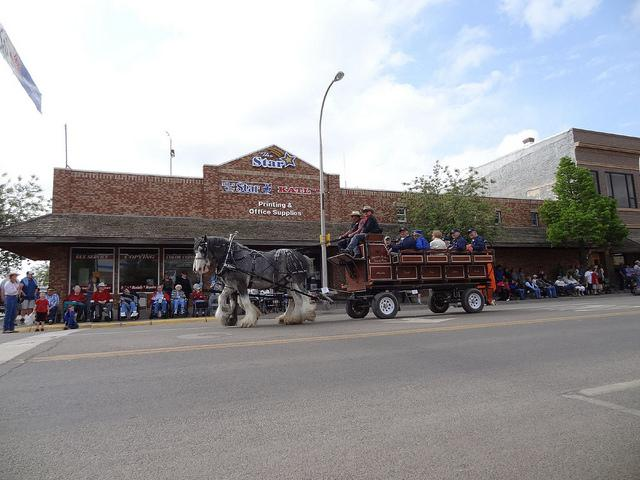What two factors are allowing the people to move? Please explain your reasoning. all correct. The horse, wheels and driver all propel the people forward. 